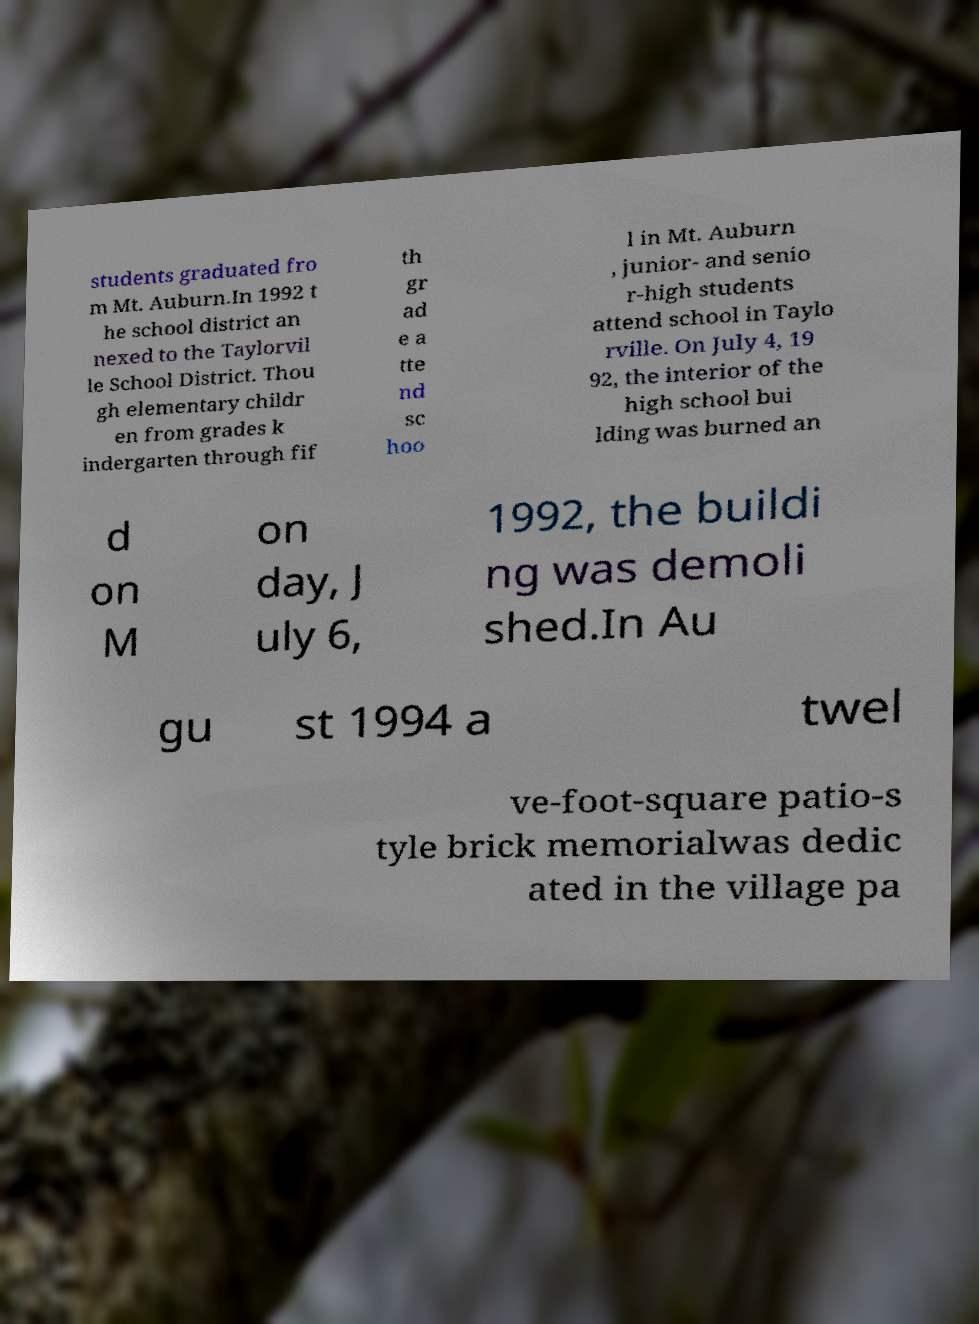What messages or text are displayed in this image? I need them in a readable, typed format. students graduated fro m Mt. Auburn.In 1992 t he school district an nexed to the Taylorvil le School District. Thou gh elementary childr en from grades k indergarten through fif th gr ad e a tte nd sc hoo l in Mt. Auburn , junior- and senio r-high students attend school in Taylo rville. On July 4, 19 92, the interior of the high school bui lding was burned an d on M on day, J uly 6, 1992, the buildi ng was demoli shed.In Au gu st 1994 a twel ve-foot-square patio-s tyle brick memorialwas dedic ated in the village pa 